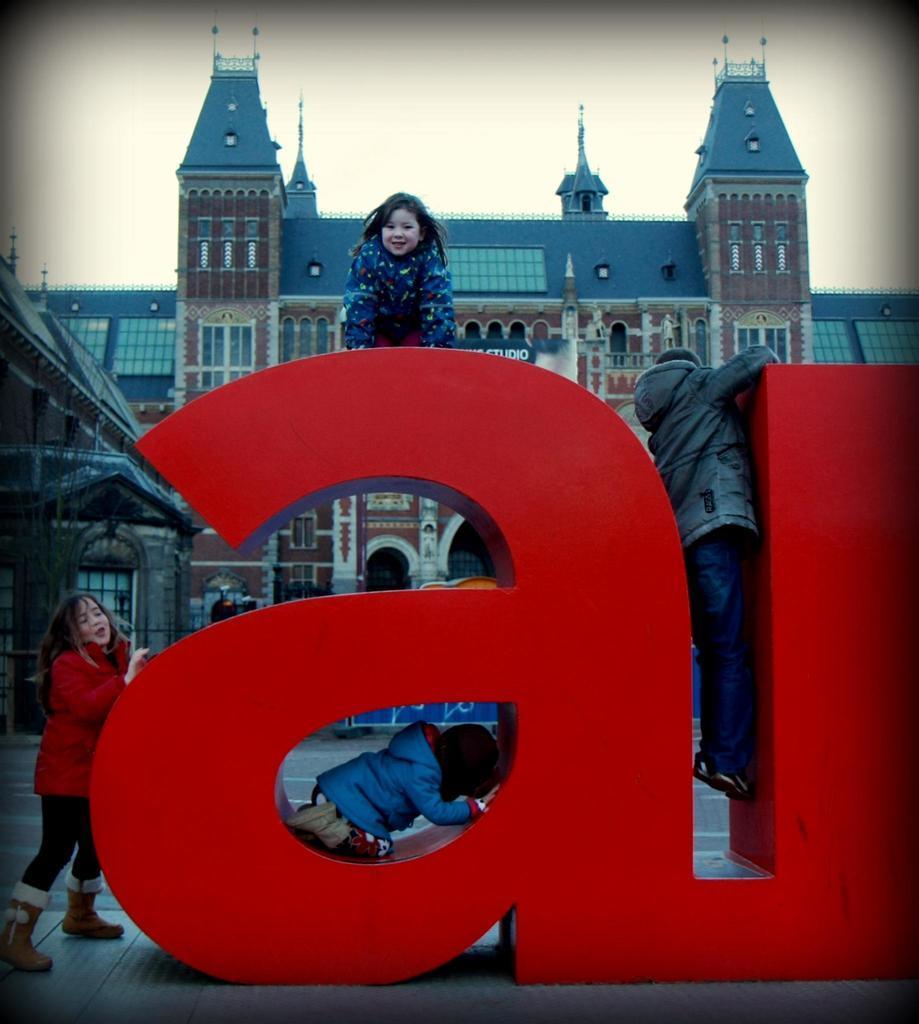Could you give a brief overview of what you see in this image? In this image there are letter blocks in the middle. There are kids playing with the letter blocks by climbing on it. On the left side there is a girl who is standing beside the letter block. In the background there is a building. At the top there is the sky. There is a girl sitting on the top of the letter. 